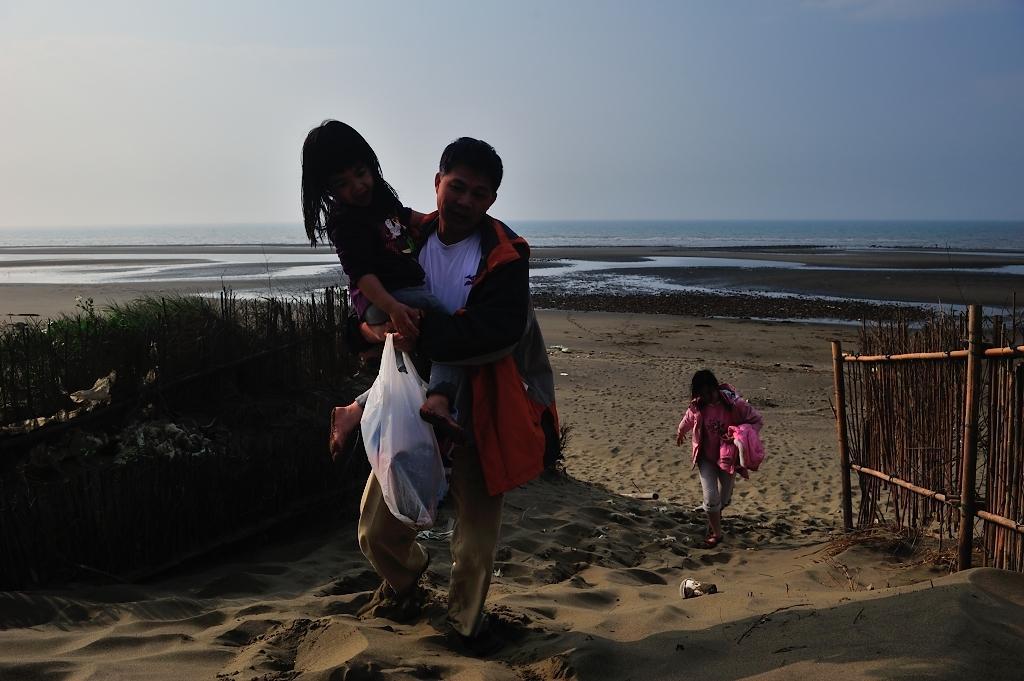Could you give a brief overview of what you see in this image? In this image in the front there is a man holding a baby in his arm and carrying a packet is walking. In the background there is a person walking and on the right side there is a fence. On the left side there are plants and in the background there is water. 